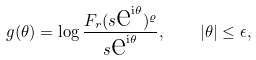<formula> <loc_0><loc_0><loc_500><loc_500>g ( \theta ) = \log \frac { F _ { r } ( s \text  e^{\text  i\theta} ) ^ { \varrho } } { s \text  e^{\text  i\theta} } , \quad | \theta | \leq \epsilon ,</formula> 